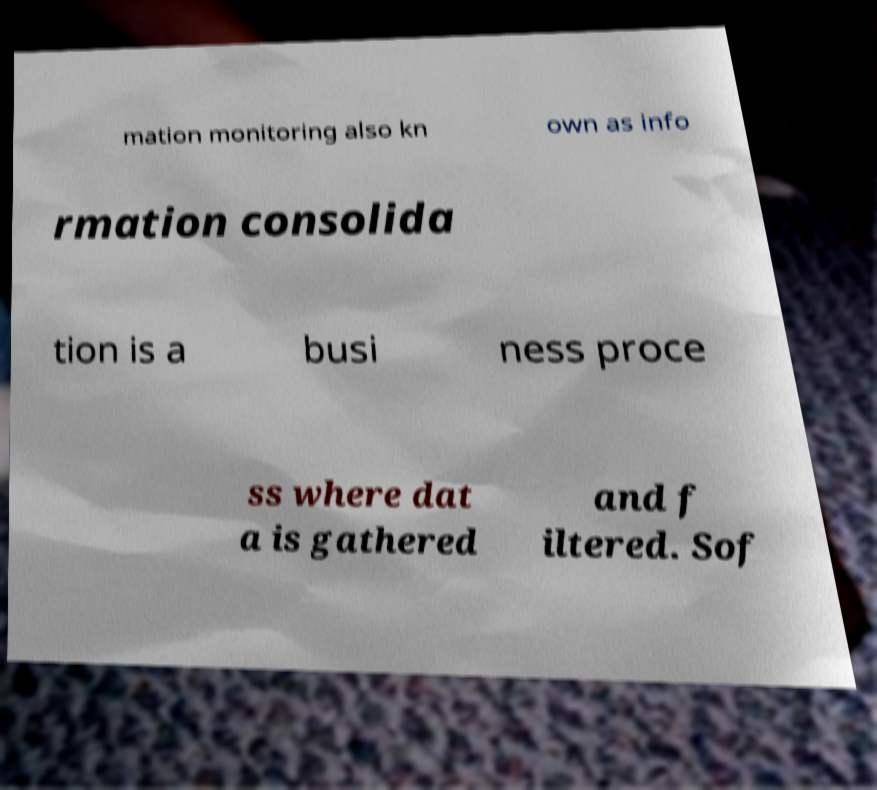Please read and relay the text visible in this image. What does it say? mation monitoring also kn own as info rmation consolida tion is a busi ness proce ss where dat a is gathered and f iltered. Sof 